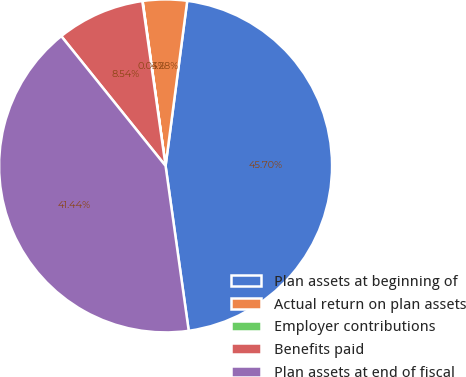<chart> <loc_0><loc_0><loc_500><loc_500><pie_chart><fcel>Plan assets at beginning of<fcel>Actual return on plan assets<fcel>Employer contributions<fcel>Benefits paid<fcel>Plan assets at end of fiscal<nl><fcel>45.7%<fcel>4.28%<fcel>0.03%<fcel>8.54%<fcel>41.44%<nl></chart> 